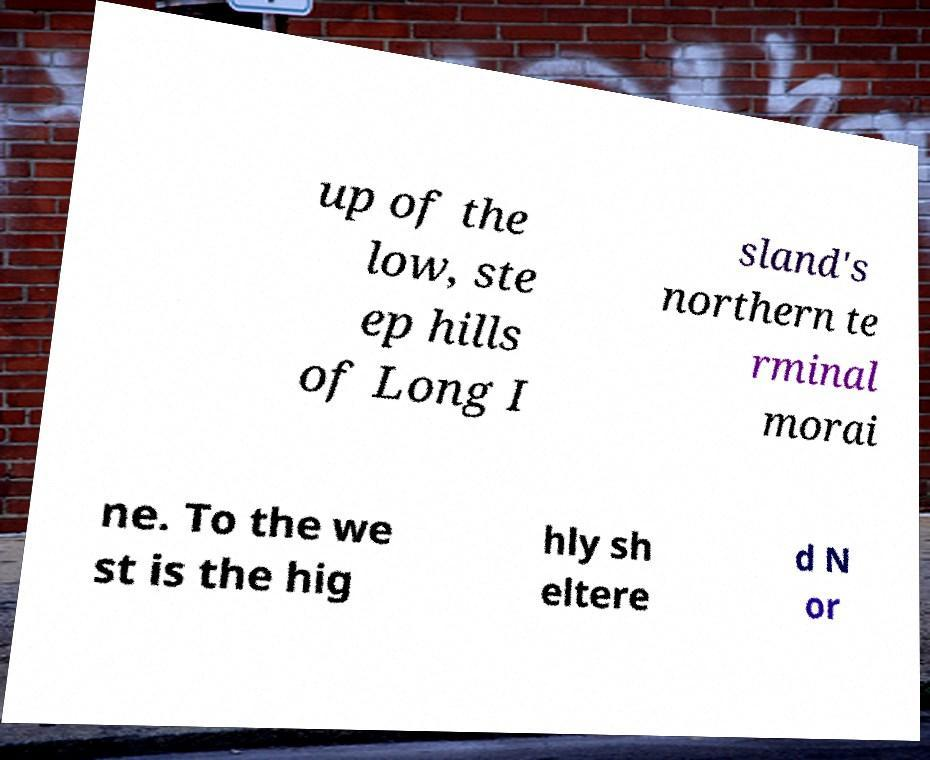Can you read and provide the text displayed in the image?This photo seems to have some interesting text. Can you extract and type it out for me? up of the low, ste ep hills of Long I sland's northern te rminal morai ne. To the we st is the hig hly sh eltere d N or 